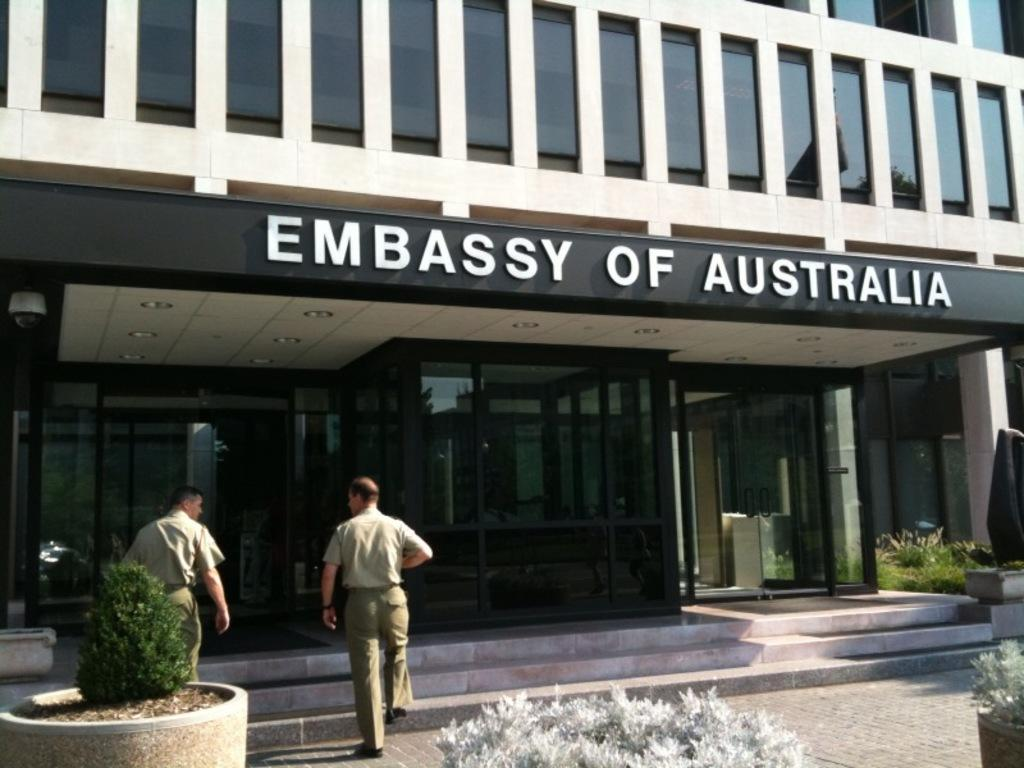What type of structure is visible in the image? There is a building in the image. What can be seen on the building in the image? There is a name board on the building in the image. What type of greenery is present in the image? There are house plants and bushes in the image. What is happening with the persons in the image? There are persons walking on the floor in the image. Can you see a cord attached to the water in the image? There is no water or cord present in the image. 